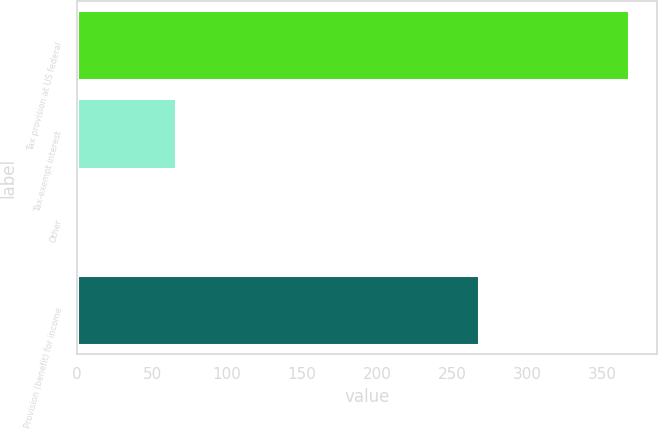Convert chart. <chart><loc_0><loc_0><loc_500><loc_500><bar_chart><fcel>Tax provision at US federal<fcel>Tax-exempt interest<fcel>Other<fcel>Provision (benefit) for income<nl><fcel>368<fcel>66<fcel>1<fcel>268<nl></chart> 